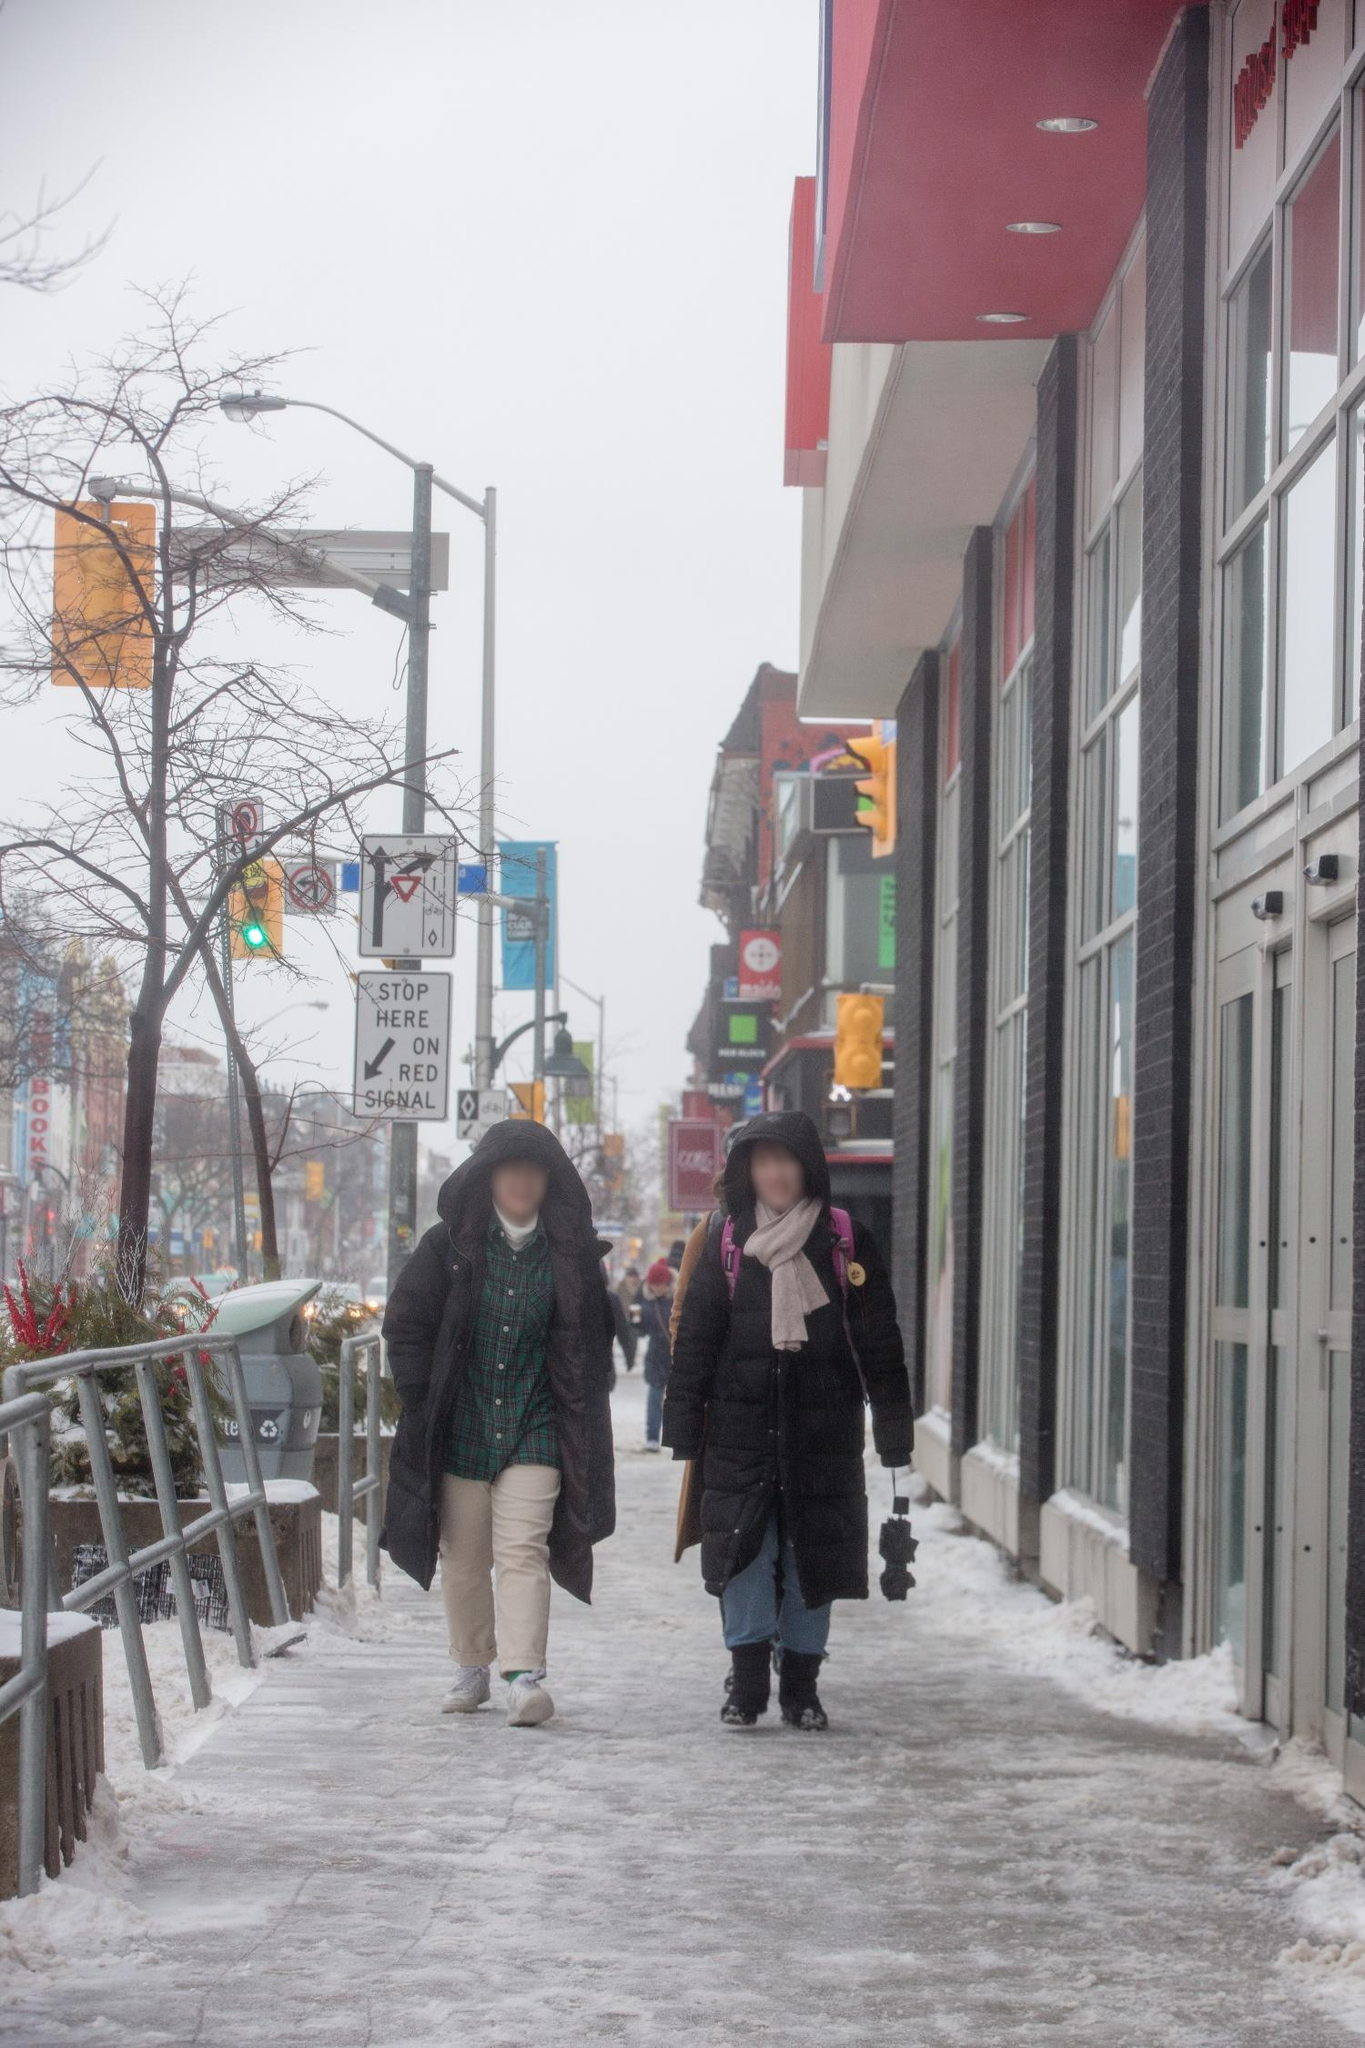Can you describe the main features of this image for me? In the midst of a cityscape, two figures are seen walking along a snowy sidewalk under a cloudy sky. On the left, one individual is bundled up in a green coat and a black hat, seemingly engaged in a conversation with a companion on the right, who is dressed in a black coat with a pink scarf draped around their neck. A striking red building forms the backdrop, providing a vivid contrast to the wintry scene. Further elements of urban life are visible in the distance, including traffic lights and various street signs, hinting at a vibrant city beyond this tranquil moment. 